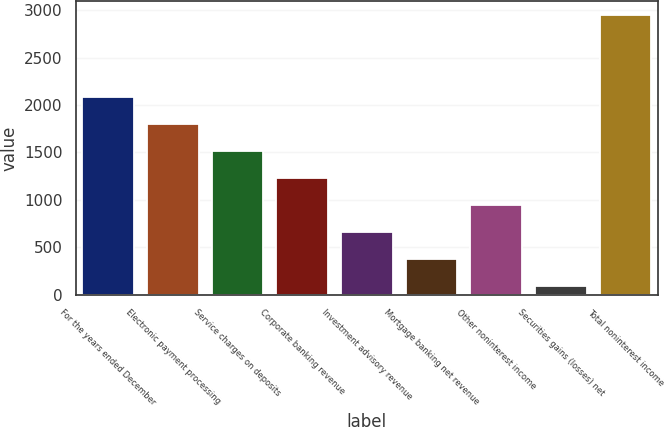Convert chart. <chart><loc_0><loc_0><loc_500><loc_500><bar_chart><fcel>For the years ended December<fcel>Electronic payment processing<fcel>Service charges on deposits<fcel>Corporate banking revenue<fcel>Investment advisory revenue<fcel>Mortgage banking net revenue<fcel>Other noninterest income<fcel>Securities gains (losses) net<fcel>Total noninterest income<nl><fcel>2088<fcel>1802<fcel>1516<fcel>1230<fcel>658<fcel>372<fcel>944<fcel>86<fcel>2946<nl></chart> 